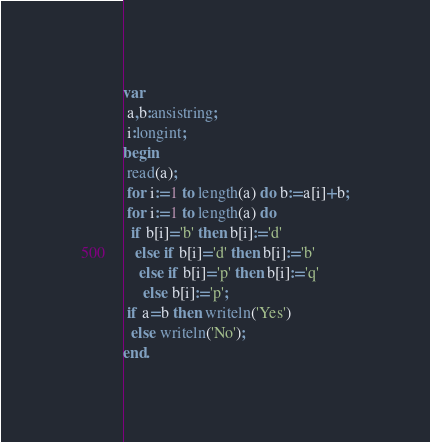<code> <loc_0><loc_0><loc_500><loc_500><_Pascal_>var
 a,b:ansistring;
 i:longint;
begin
 read(a);
 for i:=1 to length(a) do b:=a[i]+b;
 for i:=1 to length(a) do 
  if b[i]='b' then b[i]:='d'
   else if b[i]='d' then b[i]:='b'
    else if b[i]='p' then b[i]:='q'
     else b[i]:='p';
 if a=b then writeln('Yes')
  else writeln('No');
end.</code> 